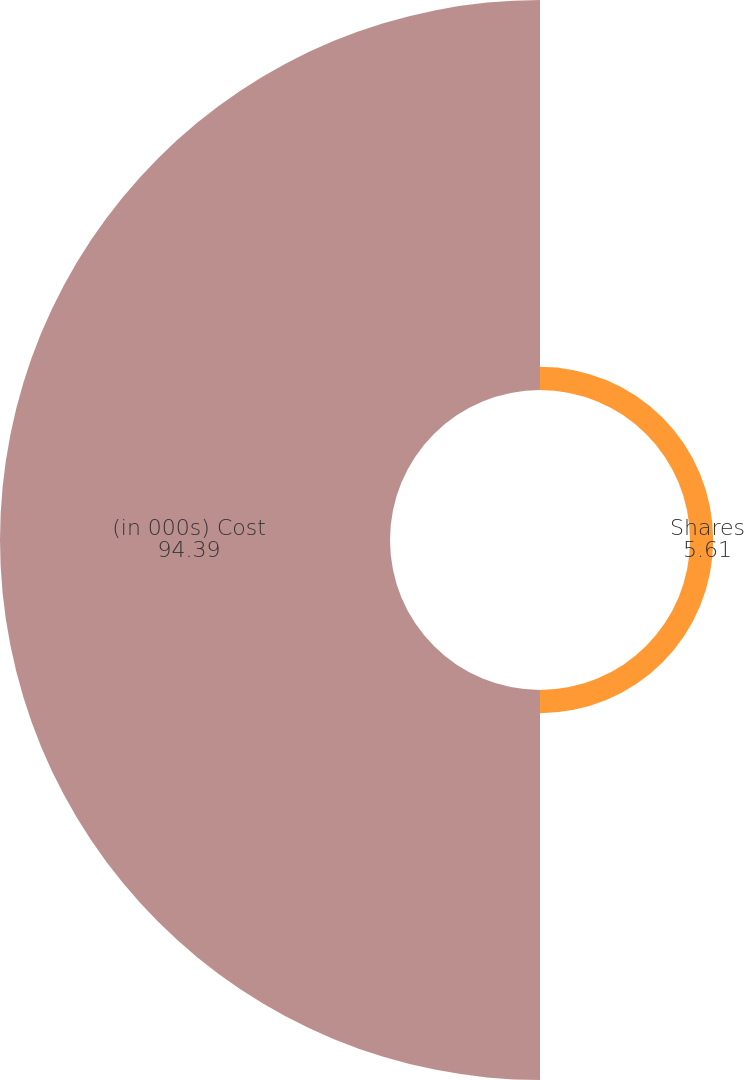Convert chart. <chart><loc_0><loc_0><loc_500><loc_500><pie_chart><fcel>Shares<fcel>(in 000s) Cost<nl><fcel>5.61%<fcel>94.39%<nl></chart> 